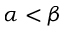<formula> <loc_0><loc_0><loc_500><loc_500>\alpha < \beta</formula> 